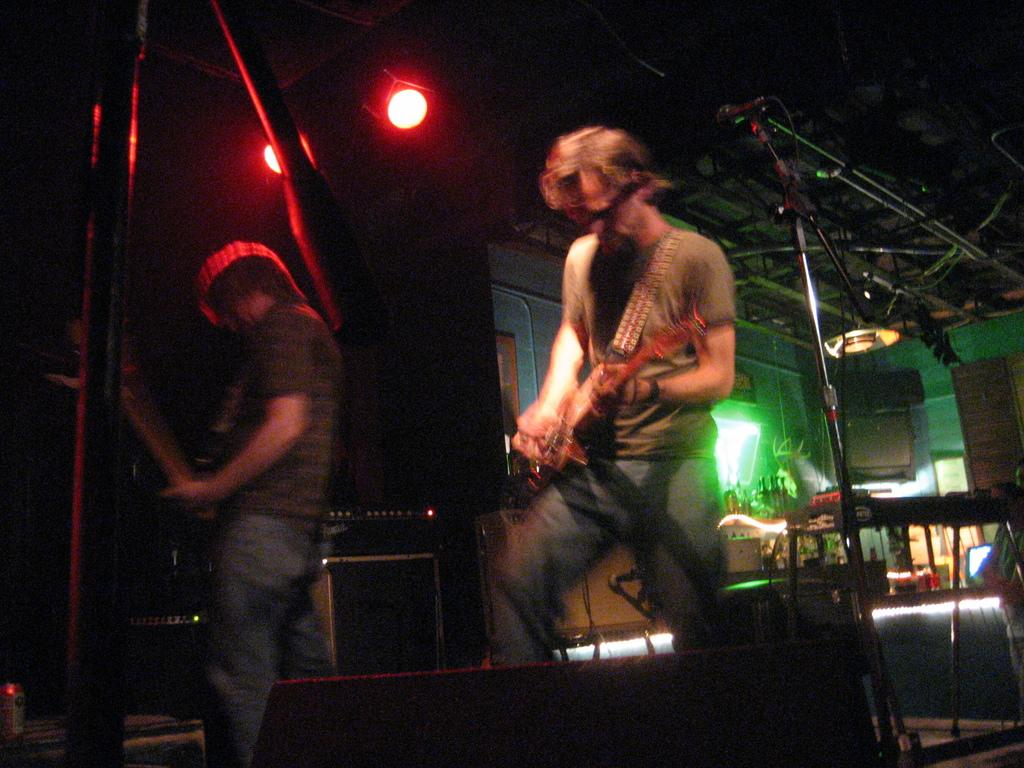How many people are in the image? There are two men in the image. What are the men doing in the image? The men are standing and playing a musical instrument. What can be seen in the background of the image? There is a microphone, a wall, and a light in the background of the image. What type of fowl can be seen interacting with the men in the image? There is no fowl present in the image; the men are playing a musical instrument without any animals. What sound is being produced by the men in the image? The specific sound being produced by the men cannot be determined from the image alone, as it depends on the musical instrument they are playing. 